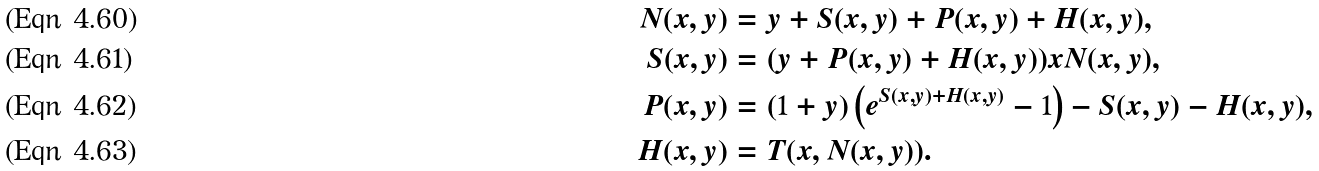Convert formula to latex. <formula><loc_0><loc_0><loc_500><loc_500>N ( x , y ) & = y + S ( x , y ) + P ( x , y ) + H ( x , y ) , \\ S ( x , y ) & = ( y + P ( x , y ) + H ( x , y ) ) x N ( x , y ) , \\ P ( x , y ) & = ( 1 + y ) \left ( e ^ { S ( x , y ) + H ( x , y ) } - 1 \right ) - S ( x , y ) - H ( x , y ) , \\ H ( x , y ) & = T ( x , N ( x , y ) ) .</formula> 